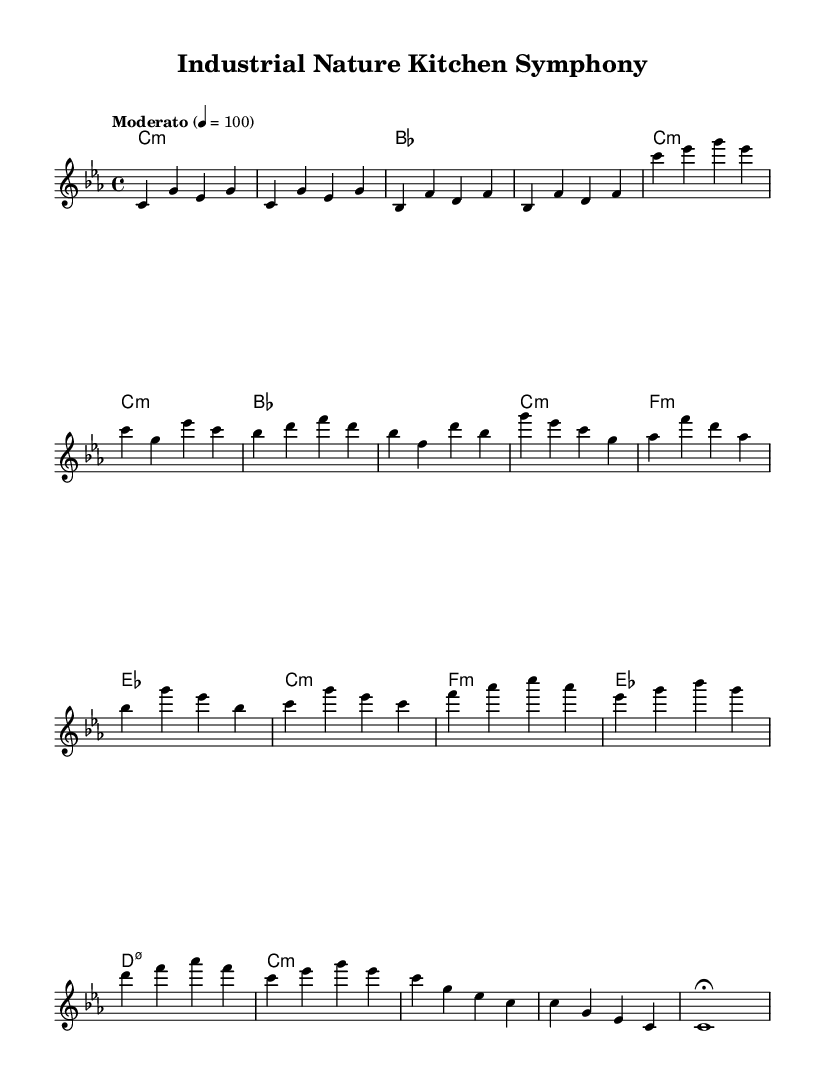What is the key signature of this music? The key signature indicated is C minor, which contains three flats. This is confirmed by identifying the key signature section at the beginning of the staff where it shows the flats.
Answer: C minor What is the time signature of this music? The time signature is 4/4, which means there are four beats in each measure and a quarter note receives one beat. This can be observed at the beginning of the score next to the key signature.
Answer: 4/4 What is the tempo marking of this composition? The tempo marking is "Moderato," and the metronome marking is indicated as 4 equals 100, which suggests a moderate pace. This is typically found at the start of the piece.
Answer: Moderato What is the first chord in the piece? The first chord in the piece is C minor, as shown in the chord section where it specifies the chords corresponding to the melody notes starting at the very beginning.
Answer: C minor How many bars are there in the Chorus section? The Chorus section consists of four bars. This can be determined by counting the measures in the section of the sheet music labeled as the Chorus.
Answer: Four Which musical form is represented in the structure of this piece? The musical form includes an Intro, Verse, Chorus, Bridge, and Outro, as laid out in the organization of the piece. This format shows clear sections that define the thematic development.
Answer: AABA What notes predominantly feature in the Bridge section? The Bridge section prominently features the notes F, A, C, and G, which create a contrasting segment compared to the other sections. By examining the written melody in that part, these notes stand out.
Answer: F, A, C, G 